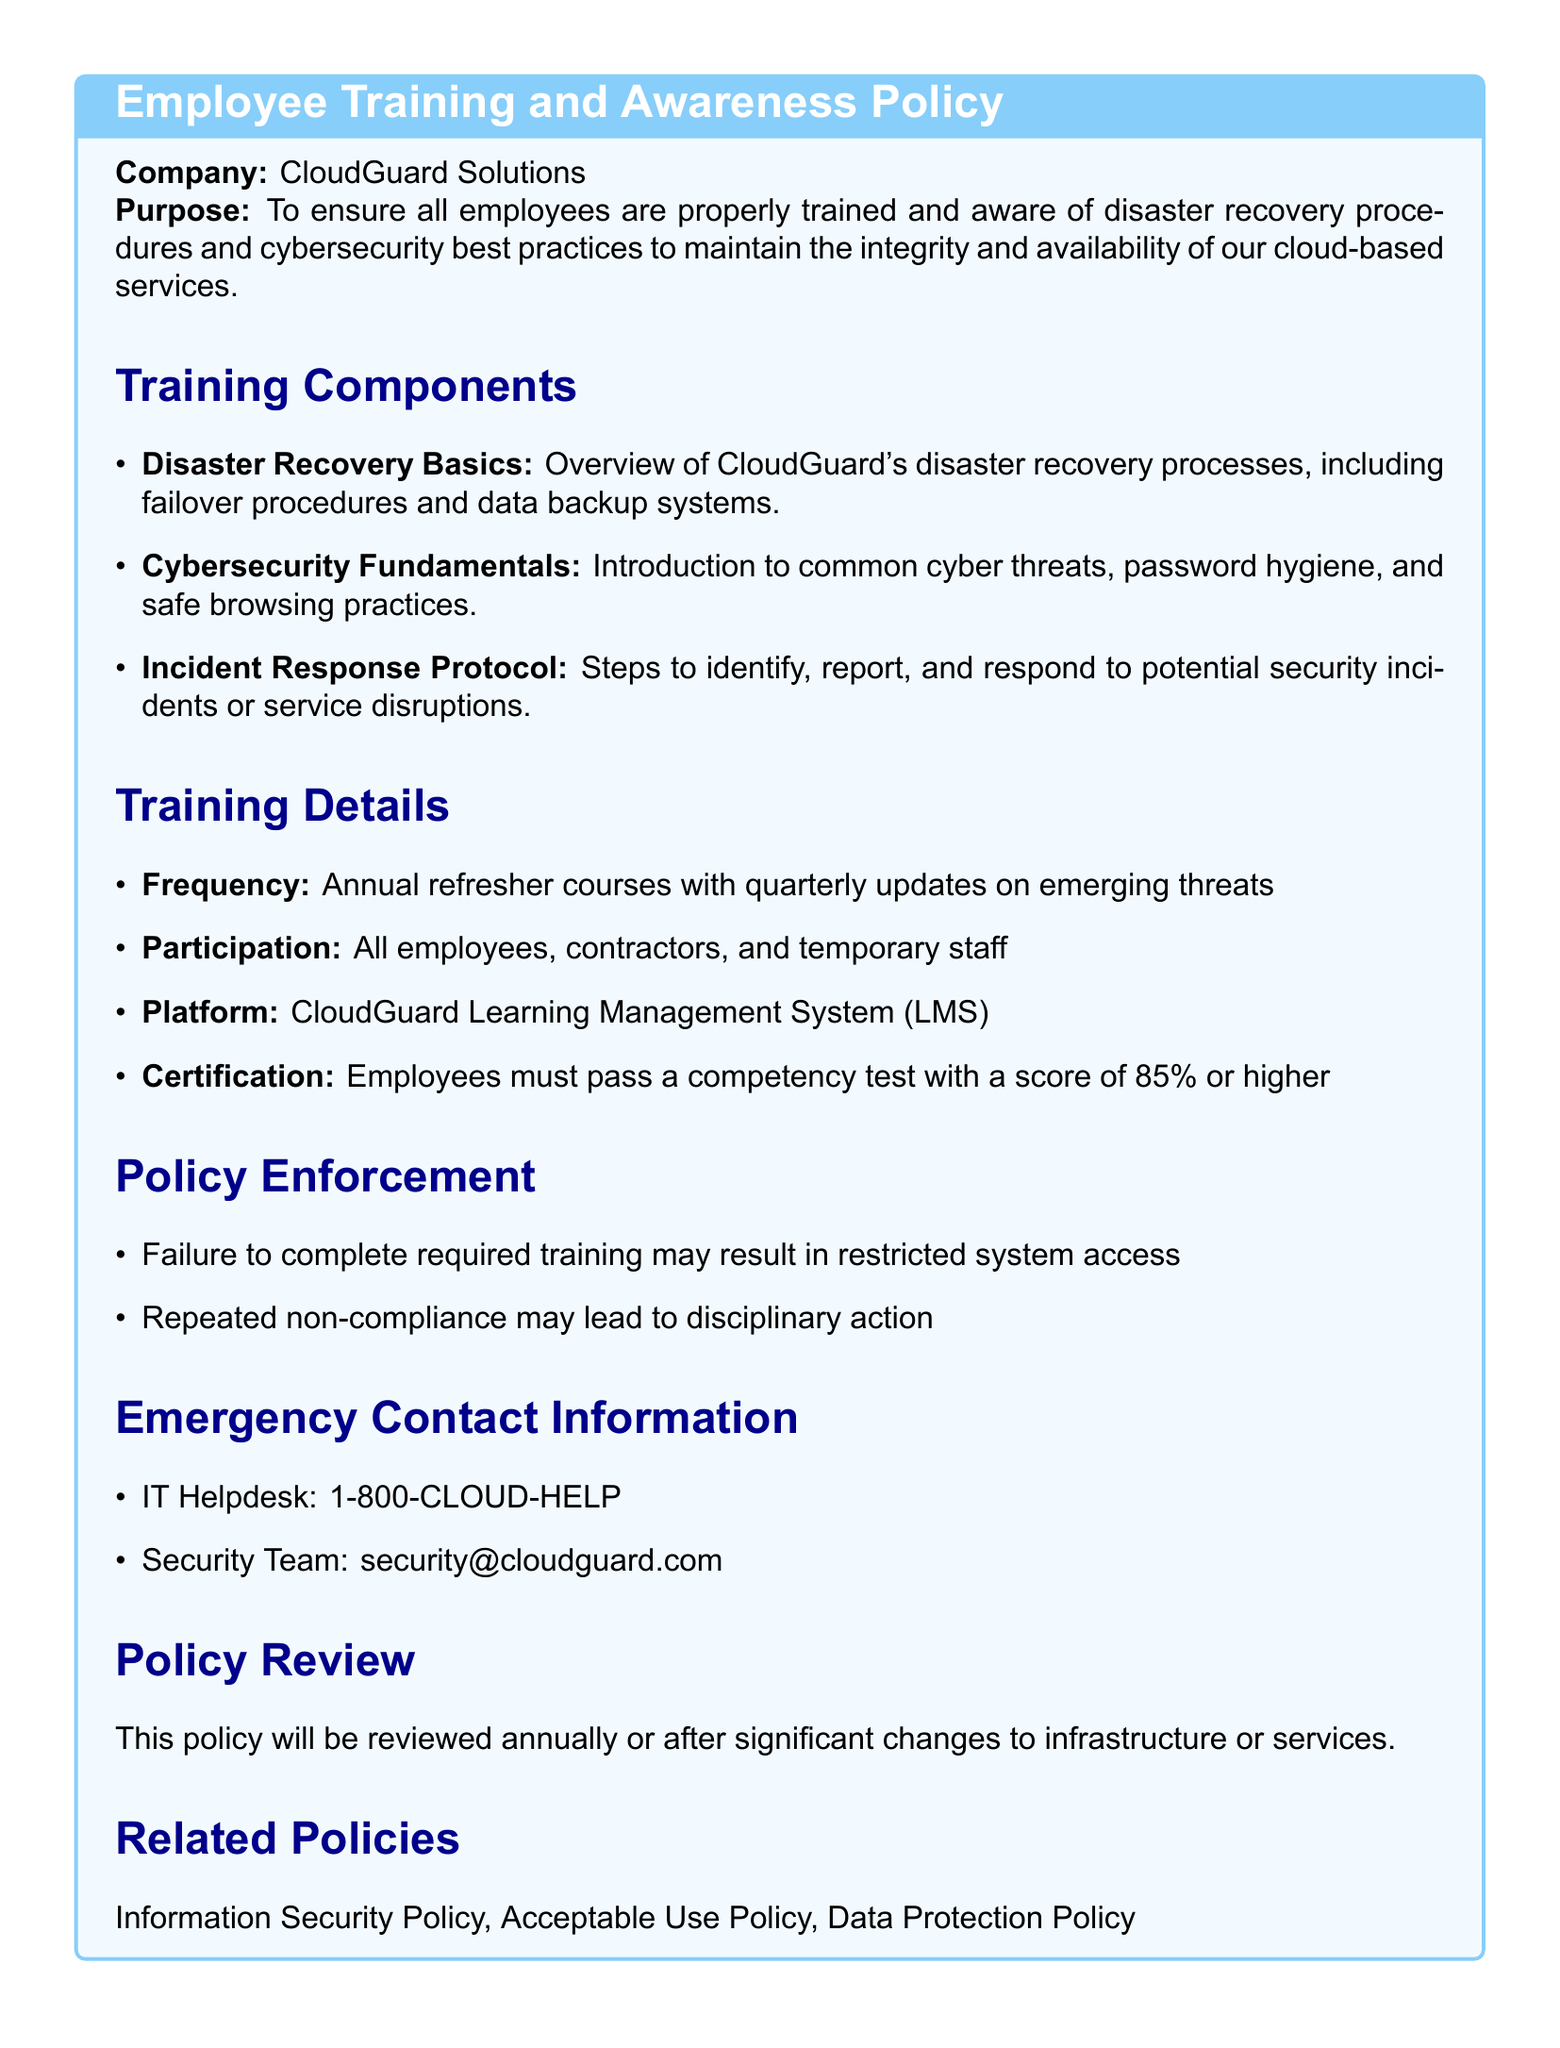what is the company name? The company name is stated at the beginning of the policy document.
Answer: CloudGuard Solutions what is the purpose of the policy? The purpose of the policy is provided in the document's introduction.
Answer: To ensure all employees are properly trained and aware of disaster recovery procedures and cybersecurity best practices what is required to pass the competency test? The document specifies the passing criteria for the competency test.
Answer: A score of 85% or higher how often are refresher courses conducted? The frequency of refresher courses is mentioned under the training details section.
Answer: Annual who must participate in the training? The participation requirements are listed in the training details section.
Answer: All employees, contractors, and temporary staff what happens if training is not completed? The consequences of not completing the required training are outlined in the policy enforcement section.
Answer: May result in restricted system access what is the emergency contact number for the IT Helpdesk? The IT Helpdesk number is specified in the emergency contact information.
Answer: 1-800-CLOUD-HELP when will the policy be reviewed? The review frequency of the policy is stated in the policy review section.
Answer: Annually what other related policies are mentioned? The related policies that correlate with the training policy are provided in a specific section.
Answer: Information Security Policy, Acceptable Use Policy, Data Protection Policy 